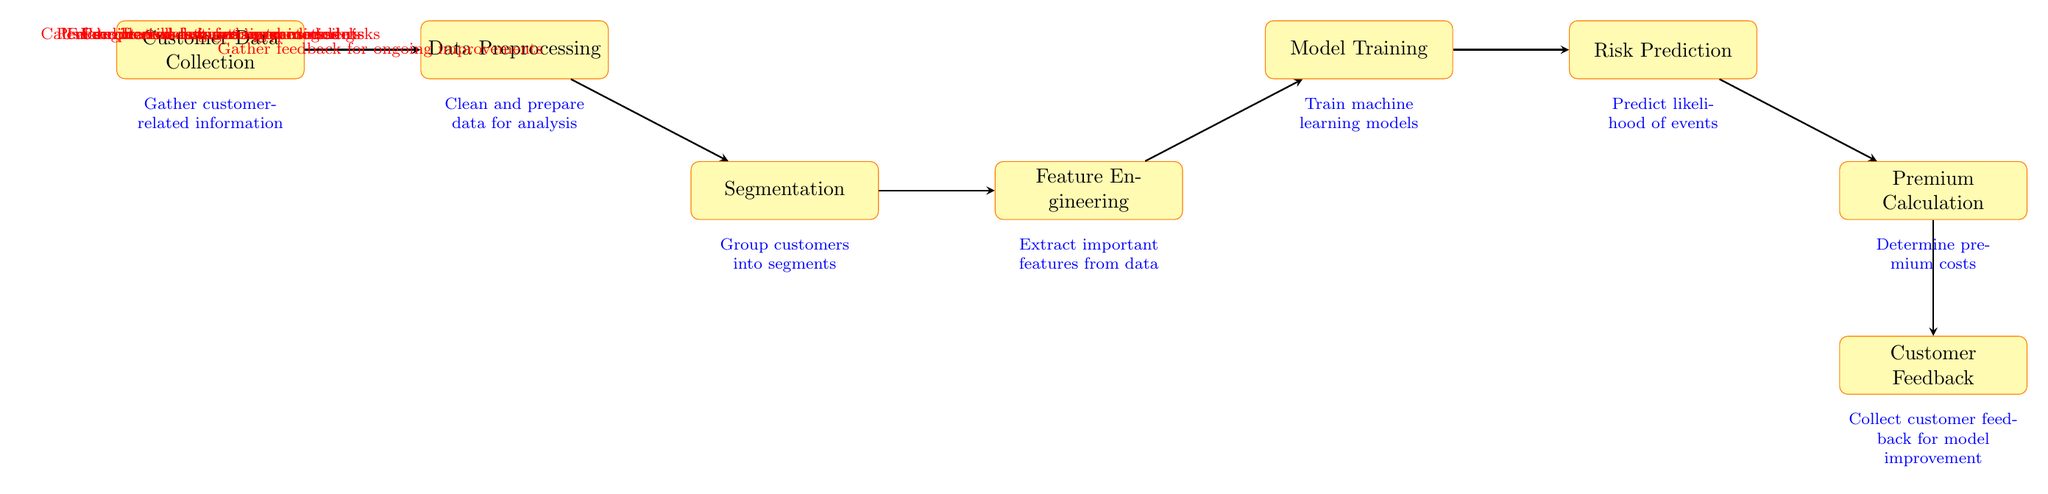What is the first step in the model? The first step in the model is "Customer Data Collection." It is the first process node that collects all relevant information from customers.
Answer: Customer Data Collection How many processes are represented in the diagram? The diagram shows a total of eight distinct processes connected sequentially, indicating the flow of the risk assessment model from data collection to customer feedback.
Answer: Eight What type of data is used in the "Data Preprocessing" step? In the "Data Preprocessing" step, the data cleaned and prepared for analysis is indicated. This step involves making sure that the collected customer data is suitable for further analysis.
Answer: Cleaned data What is the outcome of the "Risk Prediction" node? The outcome of the "Risk Prediction" node is to predict the likelihood of events. This involves using the model to determine the potential risks associated with various customer segments.
Answer: Likelihood of events Which two processes are directly connected by an arrow? The "Segmentation" process is directly connected to the "Feature Engineering" process by an arrow, indicating that after customer segments are identified, important features are extracted for model training.
Answer: Segmentation and Feature Engineering What is the connection between "Model Training" and "Risk Prediction"? The connection indicates that "Risk Prediction" uses the models trained in the "Model Training" step, highlighting that the training directly informs risk likelihood evaluations.
Answer: Trained models What happens after "Premium Calculation"? After "Premium Calculation," the diagram shows that the next step is "Customer Feedback," which involves gathering responses to improve future models and premium assessments.
Answer: Customer Feedback What do the red annotations in the diagram signify? The red annotations indicate specific actions or processes performed at each stage, describing how each step feeds into the next of the overall risk assessment model workflow.
Answer: Specific actions or processes 